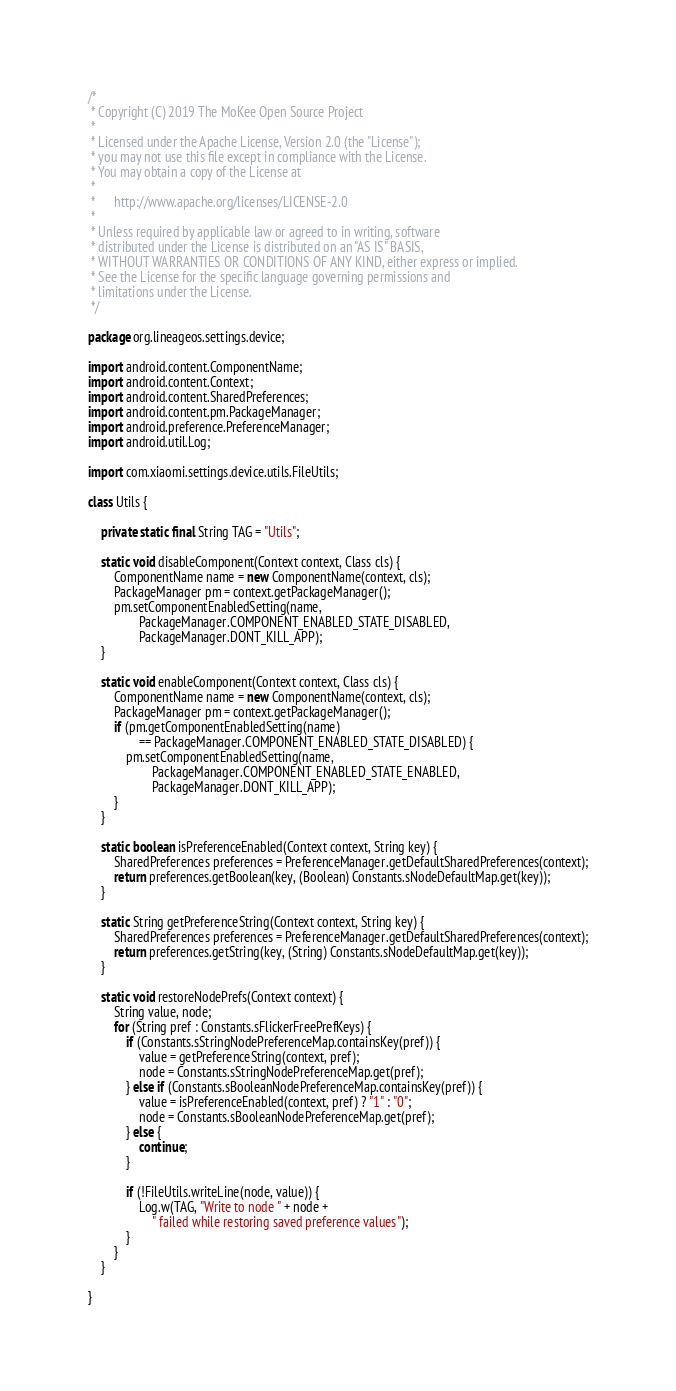Convert code to text. <code><loc_0><loc_0><loc_500><loc_500><_Java_>/*
 * Copyright (C) 2019 The MoKee Open Source Project
 *
 * Licensed under the Apache License, Version 2.0 (the "License");
 * you may not use this file except in compliance with the License.
 * You may obtain a copy of the License at
 *
 *      http://www.apache.org/licenses/LICENSE-2.0
 *
 * Unless required by applicable law or agreed to in writing, software
 * distributed under the License is distributed on an "AS IS" BASIS,
 * WITHOUT WARRANTIES OR CONDITIONS OF ANY KIND, either express or implied.
 * See the License for the specific language governing permissions and
 * limitations under the License.
 */

package org.lineageos.settings.device;

import android.content.ComponentName;
import android.content.Context;
import android.content.SharedPreferences;
import android.content.pm.PackageManager;
import android.preference.PreferenceManager;
import android.util.Log;

import com.xiaomi.settings.device.utils.FileUtils;

class Utils {

    private static final String TAG = "Utils";

    static void disableComponent(Context context, Class cls) {
        ComponentName name = new ComponentName(context, cls);
        PackageManager pm = context.getPackageManager();
        pm.setComponentEnabledSetting(name,
                PackageManager.COMPONENT_ENABLED_STATE_DISABLED,
                PackageManager.DONT_KILL_APP);
    }

    static void enableComponent(Context context, Class cls) {
        ComponentName name = new ComponentName(context, cls);
        PackageManager pm = context.getPackageManager();
        if (pm.getComponentEnabledSetting(name)
                == PackageManager.COMPONENT_ENABLED_STATE_DISABLED) {
            pm.setComponentEnabledSetting(name,
                    PackageManager.COMPONENT_ENABLED_STATE_ENABLED,
                    PackageManager.DONT_KILL_APP);
        }
    }

    static boolean isPreferenceEnabled(Context context, String key) {
        SharedPreferences preferences = PreferenceManager.getDefaultSharedPreferences(context);
        return preferences.getBoolean(key, (Boolean) Constants.sNodeDefaultMap.get(key));
    }

    static String getPreferenceString(Context context, String key) {
        SharedPreferences preferences = PreferenceManager.getDefaultSharedPreferences(context);
        return preferences.getString(key, (String) Constants.sNodeDefaultMap.get(key));
    }

    static void restoreNodePrefs(Context context) {
        String value, node;
        for (String pref : Constants.sFlickerFreePrefKeys) {
            if (Constants.sStringNodePreferenceMap.containsKey(pref)) {
                value = getPreferenceString(context, pref);
                node = Constants.sStringNodePreferenceMap.get(pref);
            } else if (Constants.sBooleanNodePreferenceMap.containsKey(pref)) {
                value = isPreferenceEnabled(context, pref) ? "1" : "0";
                node = Constants.sBooleanNodePreferenceMap.get(pref);
            } else {
                continue;
            }

            if (!FileUtils.writeLine(node, value)) {
                Log.w(TAG, "Write to node " + node +
                    " failed while restoring saved preference values");
            }
        }
    }

}
</code> 